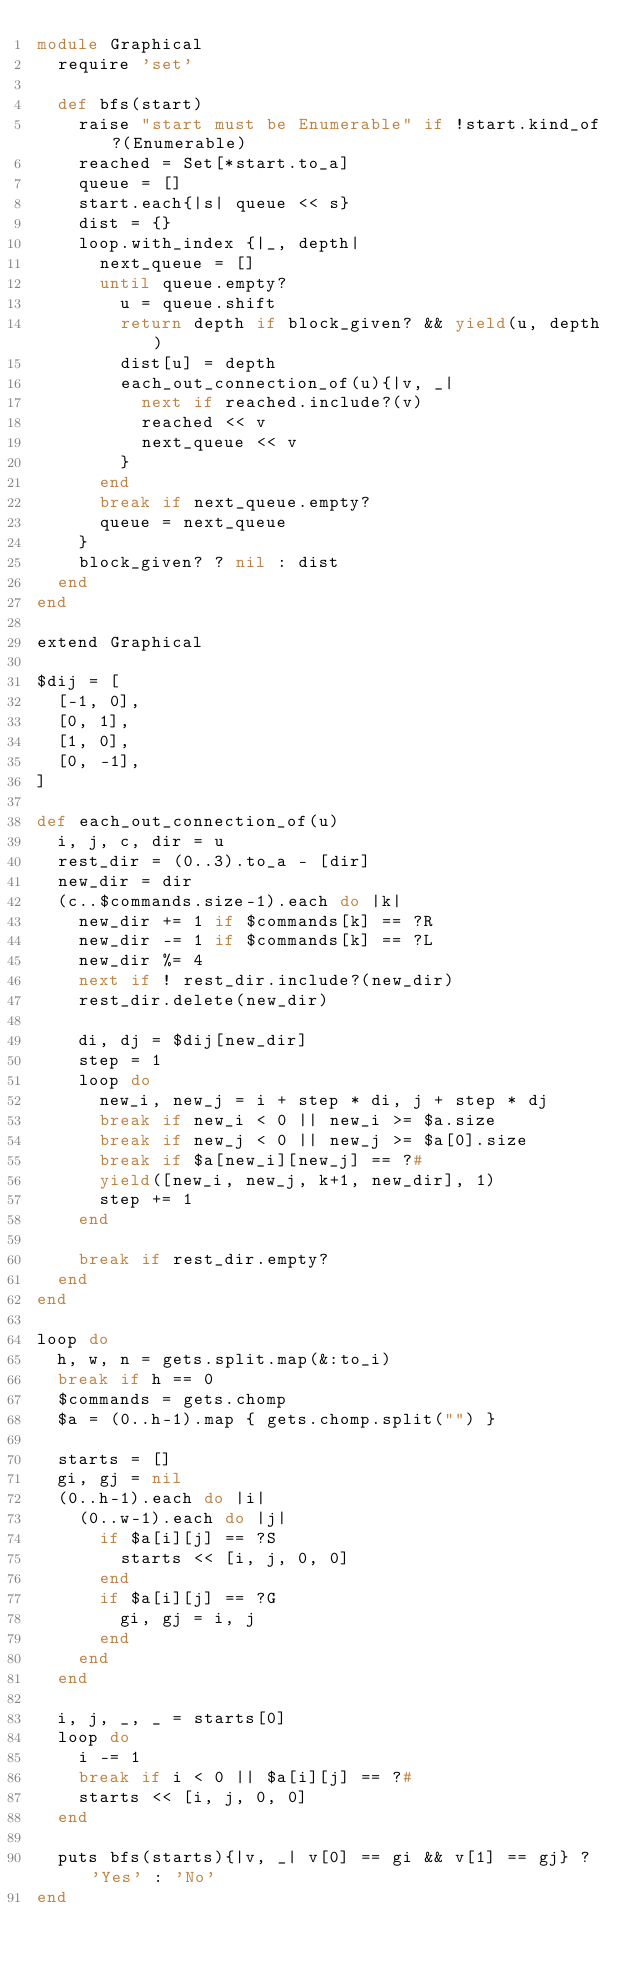<code> <loc_0><loc_0><loc_500><loc_500><_Ruby_>module Graphical
	require 'set'

	def bfs(start)
		raise "start must be Enumerable" if !start.kind_of?(Enumerable)
		reached = Set[*start.to_a]
		queue = []
		start.each{|s| queue << s}
		dist = {}
		loop.with_index {|_, depth|
			next_queue = []
			until queue.empty?
				u = queue.shift
				return depth if block_given? && yield(u, depth)
				dist[u] = depth
				each_out_connection_of(u){|v, _|
					next if reached.include?(v)
					reached << v
					next_queue << v
				}
			end
			break if next_queue.empty?
			queue = next_queue
		}
		block_given? ? nil : dist
	end
end

extend Graphical

$dij = [
	[-1, 0],
	[0, 1],
	[1, 0],
	[0, -1],
]

def each_out_connection_of(u)
	i, j, c, dir = u
	rest_dir = (0..3).to_a - [dir]
	new_dir = dir
	(c..$commands.size-1).each do |k|
		new_dir += 1 if $commands[k] == ?R
		new_dir -= 1 if $commands[k] == ?L
		new_dir %= 4
		next if ! rest_dir.include?(new_dir)
		rest_dir.delete(new_dir)

		di, dj = $dij[new_dir]
		step = 1
		loop do
			new_i, new_j = i + step * di, j + step * dj
			break if new_i < 0 || new_i >= $a.size
			break if new_j < 0 || new_j >= $a[0].size
			break if $a[new_i][new_j] == ?#
			yield([new_i, new_j, k+1, new_dir], 1)
			step += 1
		end
		
		break if rest_dir.empty?
	end
end

loop do
	h, w, n = gets.split.map(&:to_i)
	break if h == 0
	$commands = gets.chomp
	$a = (0..h-1).map { gets.chomp.split("") }

	starts = []
	gi, gj = nil
	(0..h-1).each do |i|
		(0..w-1).each do |j|
			if $a[i][j] == ?S
				starts << [i, j, 0, 0]
			end
			if $a[i][j] == ?G
				gi, gj = i, j
			end
		end
	end

	i, j, _, _ = starts[0]
	loop do
		i -= 1
		break if i < 0 || $a[i][j] == ?#
		starts << [i, j, 0, 0]
	end

	puts bfs(starts){|v, _| v[0] == gi && v[1] == gj} ? 'Yes' : 'No'
end</code> 